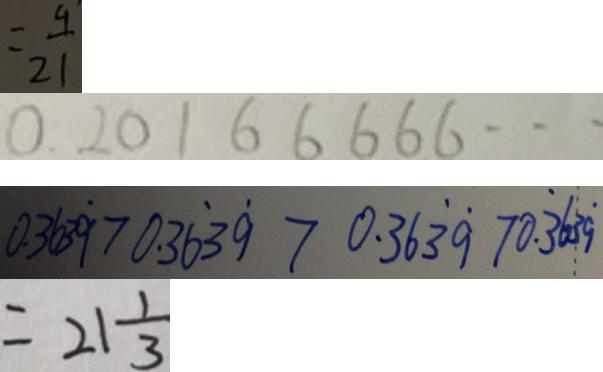Convert formula to latex. <formula><loc_0><loc_0><loc_500><loc_500>= \frac { 9 } { 2 1 } 
 0 . 2 0 1 6 6 6 6 6 \cdots 
 0 . 3 6 3 \dot { 9 } > 0 . 3 \dot { 6 } 3 \dot { 9 } > 0 . 3 6 \dot { 3 } \dot { 9 } > 0 . \dot { 3 } 6 3 \dot { 9 } 
 = 2 1 \frac { 1 } { 3 }</formula> 